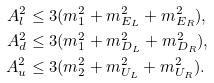Convert formula to latex. <formula><loc_0><loc_0><loc_500><loc_500>A _ { l } ^ { 2 } & \leq 3 ( m _ { 1 } ^ { 2 } + m _ { E _ { L } } ^ { 2 } + m _ { E _ { R } } ^ { 2 } ) , \\ A _ { d } ^ { 2 } & \leq 3 ( m _ { 1 } ^ { 2 } + m _ { D _ { L } } ^ { 2 } + m _ { D _ { R } } ^ { 2 } ) , \\ A _ { u } ^ { 2 } & \leq 3 ( m _ { 2 } ^ { 2 } + m _ { U _ { L } } ^ { 2 } + m _ { U _ { R } } ^ { 2 } ) .</formula> 